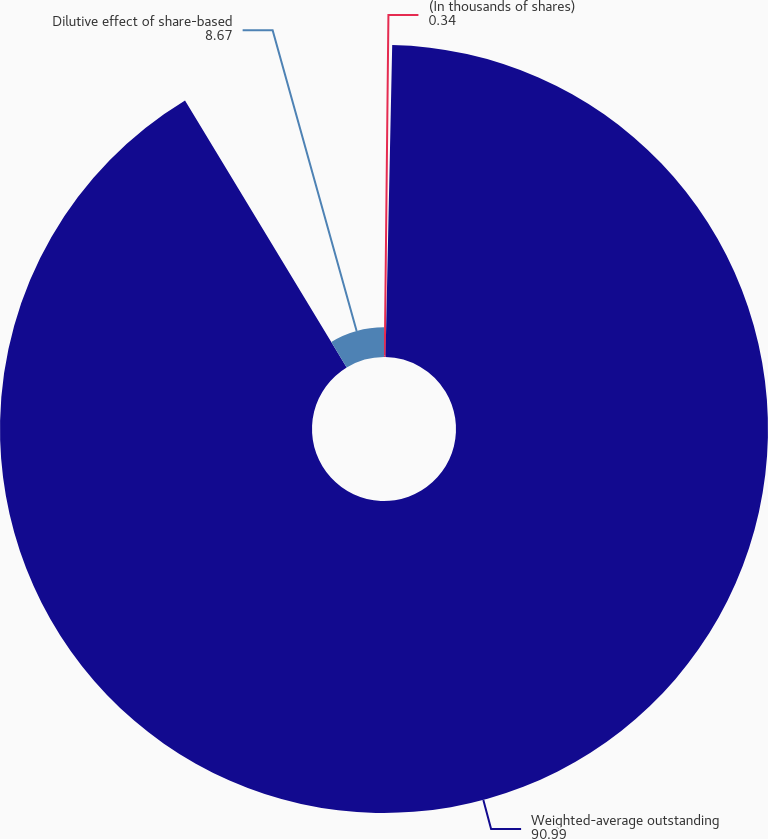<chart> <loc_0><loc_0><loc_500><loc_500><pie_chart><fcel>(In thousands of shares)<fcel>Weighted-average outstanding<fcel>Dilutive effect of share-based<nl><fcel>0.34%<fcel>90.99%<fcel>8.67%<nl></chart> 